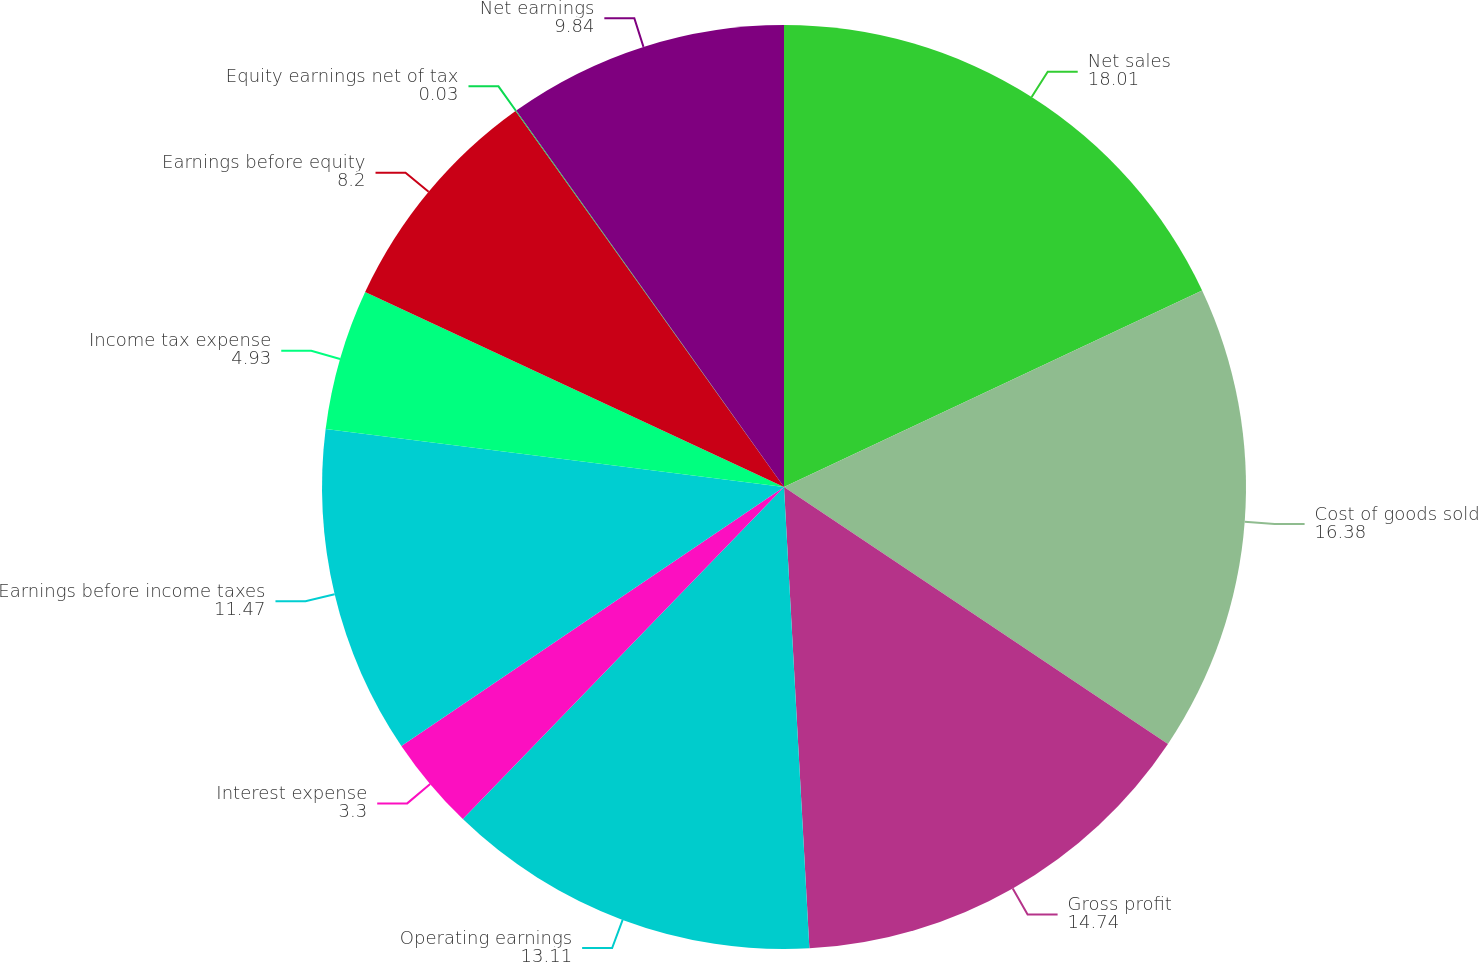Convert chart to OTSL. <chart><loc_0><loc_0><loc_500><loc_500><pie_chart><fcel>Net sales<fcel>Cost of goods sold<fcel>Gross profit<fcel>Operating earnings<fcel>Interest expense<fcel>Earnings before income taxes<fcel>Income tax expense<fcel>Earnings before equity<fcel>Equity earnings net of tax<fcel>Net earnings<nl><fcel>18.01%<fcel>16.38%<fcel>14.74%<fcel>13.11%<fcel>3.3%<fcel>11.47%<fcel>4.93%<fcel>8.2%<fcel>0.03%<fcel>9.84%<nl></chart> 